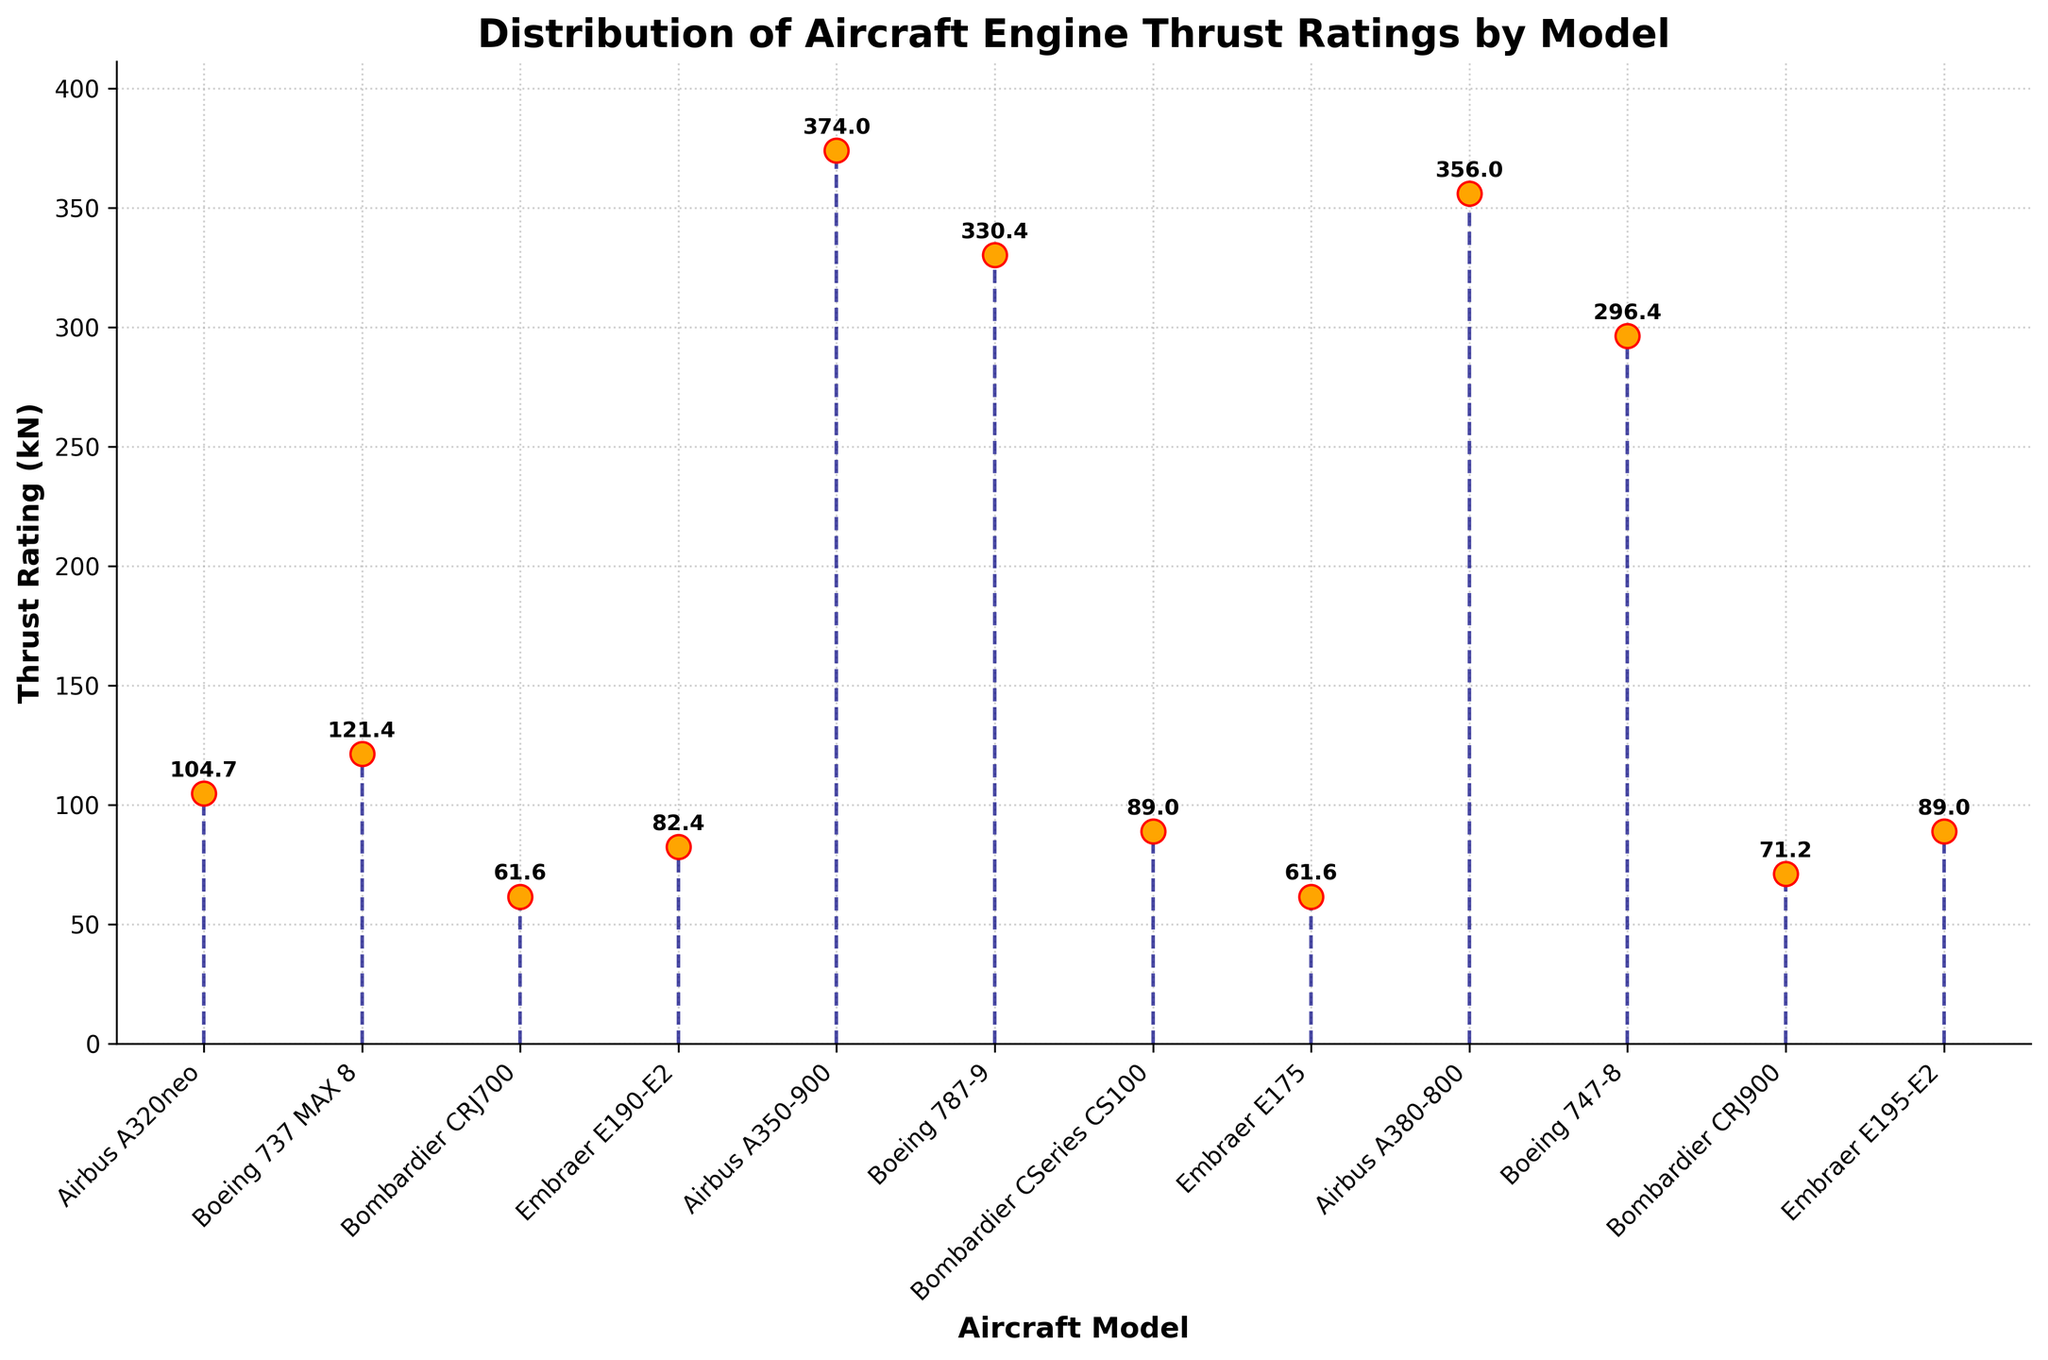What's the title of the plot? The title is displayed prominently at the top of the figure. It provides a summary of what the plot represents.
Answer: Distribution of Aircraft Engine Thrust Ratings by Model What does the x-axis represent? The x-axis represents the different aircraft models. This is indicated by the labels along the axis and the axis title.
Answer: Aircraft Model How many different aircraft models are presented in the plot? Count the number of distinct labels on the x-axis that correspond to different aircraft models.
Answer: 12 Which aircraft model has the highest thrust rating? Identify the stem (or marker) that reaches the highest point on the y-axis and look at the corresponding x-axis label.
Answer: Airbus A350-900 Which aircraft model has the lowest thrust rating? Identify the stem (or marker) that reaches the lowest point on the y-axis (above the zero baseline) and look at the corresponding x-axis label.
Answer: Bombardier CRJ700 and Embraer E175 What is the thrust rating of the Boeing 787-9? Locate the stem corresponding to Boeing 787-9 and read the exact value either off the plot text annotation or the y-axis.
Answer: 330.4 kN What's the average thrust rating of all the aircraft models? Sum the thrust ratings of all models and divide by the number of models. Sum: 104.7 + 121.4 + 61.6 + 82.4 + 374 + 330.4 + 89.0 + 61.6 + 356 + 296.4 + 71.2 + 89.0 = 2038.7. Average: 2038.7 / 12 = 169.9 kN
Answer: 169.9 kN Which two aircraft models have the same thrust rating? Identify any two stems that reach the same value on the y-axis and check their x-axis labels.
Answer: Bombardier CRJ700 and Embraer E175; Bombardier CSeries CS100 and Embraer E195-E2 What is the difference in thrust rating between the Airbus A380-800 and the Embraer E190-E2? Find the thrust rating values of Airbus A380-800 (356 kN) and Embraer E190-E2 (82.4 kN) and subtract the smaller from the larger.
Answer: 273.6 kN What's the color of the markers used in the plot? Identify the color of the markers, which are dots or shapes at the ends of the stems, from visual inspection.
Answer: Orange How does the thrust rating of the Bombardier CRJ900 compare to that of the Bombardier CRJ700? Find the thrust ratings for both models (71.2 kN for CRJ900 and 61.6 kN for CRJ700) and compare them.
Answer: CRJ900 has a higher thrust rating 